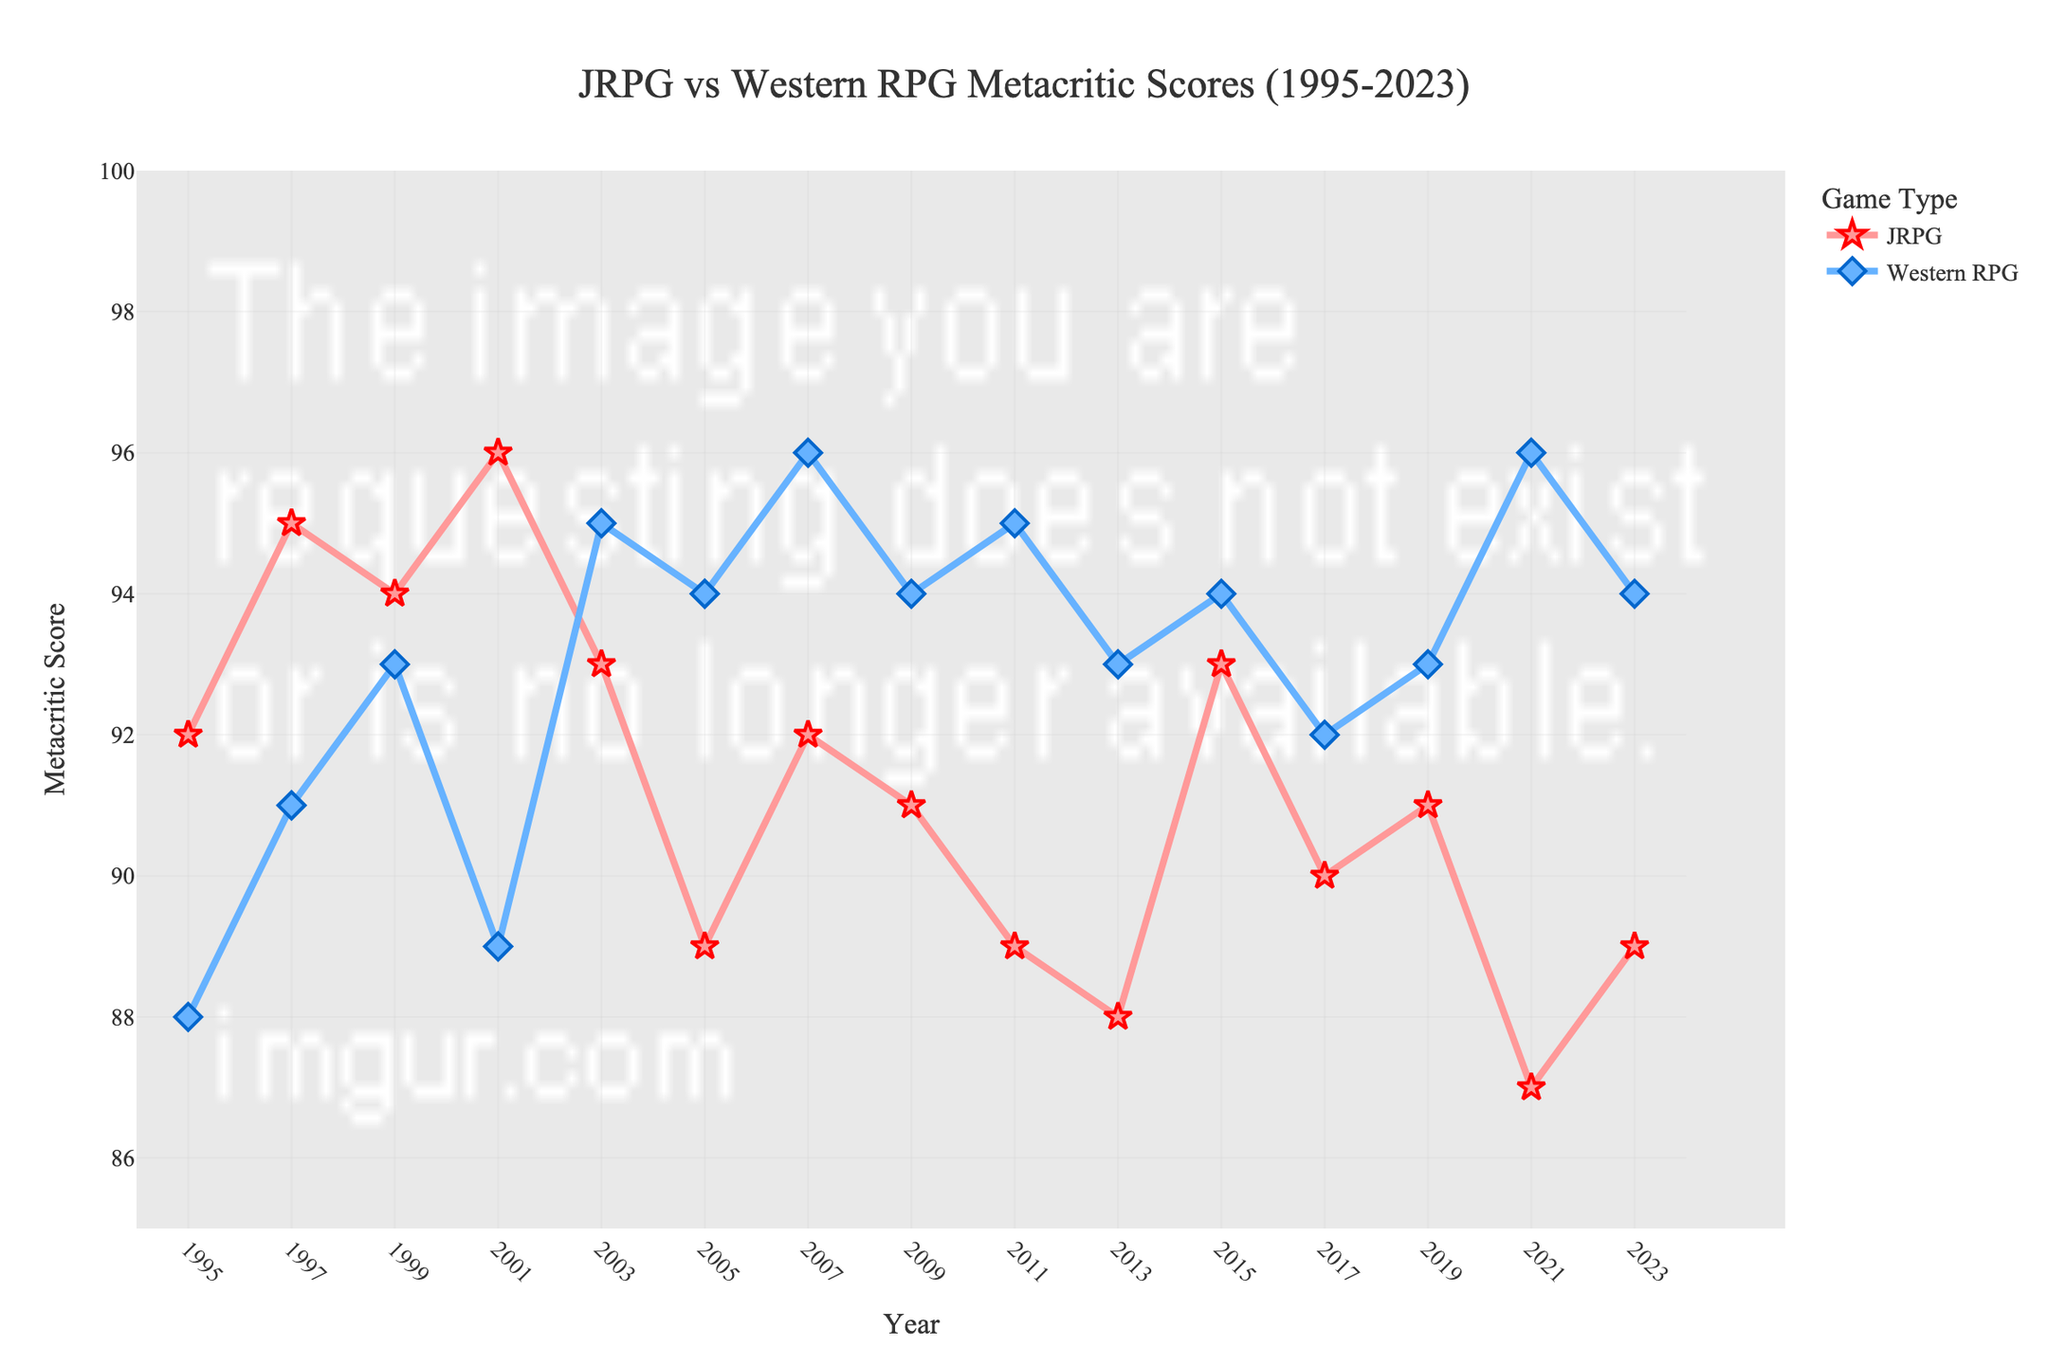What year did the Top Western RPG have its highest Metacritic score? Look for the year with the highest point on the Top Western RPG line. This is in 2021 with a score of 96.
Answer: 2021 Which game type had a higher Metacritic score in 2007, and by how much? In 2007, the Top Western RPG score was 96, while the Top JRPG score was 92. The Western RPG score was higher by 96 - 92 = 4 points.
Answer: Western RPG, by 4 points Over the period from 1995 to 2023, which game type had a higher average Metacritic score? Sum the Metacritic scores for each game type and divide by the number of data points (15). (Top JRPG: (92+95+94+96+93+89+92+91+89+88+93+90+91+87+89)/15 = 91.53) and (Top Western RPG (88+91+93+89+95+94+96+94+95+93+94+92+93+96+94)/15 = 93.33). Western RPGs have a higher average score.
Answer: Western RPGs What is the smallest Metacritic score recorded for Top JRPGs and in which year did it occur? Locate the lowest point on the Top JRPG line. It occurred in 2021 with a score of 87.
Answer: 87, in 2021 Between 2003 and 2009, which game type showed a more consistent score trend and how was this determined? Consistency can be assessed by looking at the variance in scores over the interval. Top JRPG scores (93, 89, 92, 91) and Top Western RPG scores (95, 94, 96, 94) show that the Top Western RPG had less fluctuation (variance: 0.67) compared to Top JRPG (variance: 1.58).
Answer: Western RPG, more consistent scores During which period did the Top JRPG Metacritic score start to consistently decrease, and what was the range of this decrease? Identify when the Top JRPG line begins to show a consistent downward trend. From 2001 (96) to 2013 (88), Top JRPG scores generally trend downward from 96 to 88.
Answer: 2001 to 2013, decreased by 8 points How many times did the Top Western RPG score reach or exceed 95 between 1995 and 2023? Count the instances where the Top Western RPG line reaches or exceeds 95. The years are 2003, 2007, 2011, and 2021.
Answer: 4 times In which year did the Top JRPG score surpass the Top Western RPG score by the largest margin? Identify the year where the gap between the two scores is maximum, with Top JRPG scoring higher. In 2001, JRPG (96) surpassed Western RPG (89) by a margin of 96 - 89 = 7 points.
Answer: 2001 